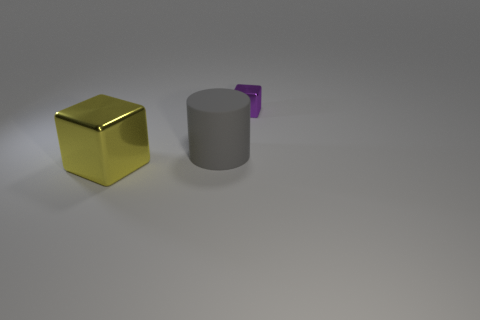How big is the object that is right of the large thing on the right side of the thing that is in front of the large gray thing?
Make the answer very short. Small. What is the color of the thing that is in front of the tiny purple metallic cube and to the right of the yellow cube?
Ensure brevity in your answer.  Gray. There is a yellow metallic cube; is its size the same as the matte cylinder left of the tiny purple metallic object?
Offer a very short reply. Yes. Is there any other thing that has the same shape as the large gray rubber object?
Give a very brief answer. No. What color is the tiny shiny object that is the same shape as the large yellow thing?
Offer a terse response. Purple. Do the rubber cylinder and the yellow cube have the same size?
Offer a very short reply. Yes. How many other objects are there of the same size as the matte object?
Offer a very short reply. 1. What number of things are either things that are in front of the small metallic thing or shiny objects that are in front of the tiny purple object?
Provide a short and direct response. 2. What shape is the other thing that is the same size as the yellow metallic thing?
Offer a terse response. Cylinder. What size is the thing that is made of the same material as the big block?
Provide a succinct answer. Small. 